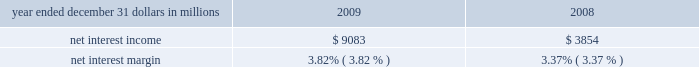Consolidated income statement review net income for 2009 was $ 2.4 billion and for 2008 was $ 914 million .
Amounts for 2009 include operating results of national city and the fourth quarter impact of a $ 687 million after-tax gain related to blackrock 2019s acquisition of bgi .
Increases in income statement comparisons to 2008 , except as noted , are primarily due to the operating results of national city .
Our consolidated income statement is presented in item 8 of this report .
Net interest income and net interest margin year ended december 31 dollars in millions 2009 2008 .
Changes in net interest income and margin result from the interaction of the volume and composition of interest-earning assets and related yields , interest-bearing liabilities and related rates paid , and noninterest-bearing sources of funding .
See statistical information 2013 analysis of year-to-year changes in net interest ( unaudited ) income and average consolidated balance sheet and net interest analysis in item 8 of this report for additional information .
Higher net interest income for 2009 compared with 2008 reflected the increase in average interest-earning assets due to national city and the improvement in the net interest margin .
The net interest margin was 3.82% ( 3.82 % ) for 2009 and 3.37% ( 3.37 % ) for 2008 .
The following factors impacted the comparison : 2022 a decrease in the rate accrued on interest-bearing liabilities of 97 basis points .
The rate accrued on interest-bearing deposits , the largest component , decreased 107 basis points .
2022 these factors were partially offset by a 45 basis point decrease in the yield on interest-earning assets .
The yield on loans , which represented the largest portion of our earning assets in 2009 , decreased 30 basis points .
2022 in addition , the impact of noninterest-bearing sources of funding decreased 7 basis points .
For comparing to the broader market , the average federal funds rate was .16% ( .16 % ) for 2009 compared with 1.94% ( 1.94 % ) for 2008 .
We expect our net interest income for 2010 will likely be modestly lower as a result of cash recoveries on purchased impaired loans in 2009 and additional run-off of higher- yielding assets , which could be mitigated by rising interest rates .
This assumes our current expectations for interest rates and economic conditions 2013 we include our current economic assumptions underlying our forward-looking statements in the cautionary statement regarding forward-looking information section of this item 7 .
Noninterest income summary noninterest income was $ 7.1 billion for 2009 and $ 2.4 billion for 2008 .
Noninterest income for 2009 included the following : 2022 the gain on blackrock/bgi transaction of $ 1.076 billion , 2022 net credit-related other-than-temporary impairments ( otti ) on debt and equity securities of $ 577 million , 2022 net gains on sales of securities of $ 550 million , 2022 gains on hedging of residential mortgage servicing rights of $ 355 million , 2022 valuation and sale income related to our commercial mortgage loans held for sale , net of hedges , of $ 107 million , 2022 gains of $ 103 million related to our blackrock ltip shares adjustment in the first quarter , and net losses on private equity and alternative investments of $ 93 million .
Noninterest income for 2008 included the following : 2022 net otti on debt and equity securities of $ 312 million , 2022 gains of $ 246 million related to our blackrock ltip shares adjustment , 2022 valuation and sale losses related to our commercial mortgage loans held for sale , net of hedges , of $ 197 million , 2022 impairment and other losses related to private equity and alternative investments of $ 180 million , 2022 income from hilliard lyons totaling $ 164 million , including the first quarter gain of $ 114 million from the sale of this business , 2022 net gains on sales of securities of $ 106 million , and 2022 a gain of $ 95 million related to the redemption of a portion of our visa class b common shares related to visa 2019s march 2008 initial public offering .
Additional analysis asset management revenue increased $ 172 million to $ 858 million in 2009 , compared with $ 686 million in 2008 .
This increase reflected improving equity markets , new business generation and a shift in assets into higher yielding equity investments during the second half of 2009 .
Assets managed totaled $ 103 billion at both december 31 , 2009 and 2008 , including the impact of national city .
The asset management group section of the business segments review section of this item 7 includes further discussion of assets under management .
Consumer services fees totaled $ 1.290 billion in 2009 compared with $ 623 million in 2008 .
Service charges on deposits totaled $ 950 million for 2009 and $ 372 million for 2008 .
Both increases were primarily driven by the impact of the national city acquisition .
Reduced consumer spending .
What was the percentage change in the asset management revenue from 2008 to 2009? 
Computations: (172 / 686)
Answer: 0.25073. Consolidated income statement review net income for 2009 was $ 2.4 billion and for 2008 was $ 914 million .
Amounts for 2009 include operating results of national city and the fourth quarter impact of a $ 687 million after-tax gain related to blackrock 2019s acquisition of bgi .
Increases in income statement comparisons to 2008 , except as noted , are primarily due to the operating results of national city .
Our consolidated income statement is presented in item 8 of this report .
Net interest income and net interest margin year ended december 31 dollars in millions 2009 2008 .
Changes in net interest income and margin result from the interaction of the volume and composition of interest-earning assets and related yields , interest-bearing liabilities and related rates paid , and noninterest-bearing sources of funding .
See statistical information 2013 analysis of year-to-year changes in net interest ( unaudited ) income and average consolidated balance sheet and net interest analysis in item 8 of this report for additional information .
Higher net interest income for 2009 compared with 2008 reflected the increase in average interest-earning assets due to national city and the improvement in the net interest margin .
The net interest margin was 3.82% ( 3.82 % ) for 2009 and 3.37% ( 3.37 % ) for 2008 .
The following factors impacted the comparison : 2022 a decrease in the rate accrued on interest-bearing liabilities of 97 basis points .
The rate accrued on interest-bearing deposits , the largest component , decreased 107 basis points .
2022 these factors were partially offset by a 45 basis point decrease in the yield on interest-earning assets .
The yield on loans , which represented the largest portion of our earning assets in 2009 , decreased 30 basis points .
2022 in addition , the impact of noninterest-bearing sources of funding decreased 7 basis points .
For comparing to the broader market , the average federal funds rate was .16% ( .16 % ) for 2009 compared with 1.94% ( 1.94 % ) for 2008 .
We expect our net interest income for 2010 will likely be modestly lower as a result of cash recoveries on purchased impaired loans in 2009 and additional run-off of higher- yielding assets , which could be mitigated by rising interest rates .
This assumes our current expectations for interest rates and economic conditions 2013 we include our current economic assumptions underlying our forward-looking statements in the cautionary statement regarding forward-looking information section of this item 7 .
Noninterest income summary noninterest income was $ 7.1 billion for 2009 and $ 2.4 billion for 2008 .
Noninterest income for 2009 included the following : 2022 the gain on blackrock/bgi transaction of $ 1.076 billion , 2022 net credit-related other-than-temporary impairments ( otti ) on debt and equity securities of $ 577 million , 2022 net gains on sales of securities of $ 550 million , 2022 gains on hedging of residential mortgage servicing rights of $ 355 million , 2022 valuation and sale income related to our commercial mortgage loans held for sale , net of hedges , of $ 107 million , 2022 gains of $ 103 million related to our blackrock ltip shares adjustment in the first quarter , and net losses on private equity and alternative investments of $ 93 million .
Noninterest income for 2008 included the following : 2022 net otti on debt and equity securities of $ 312 million , 2022 gains of $ 246 million related to our blackrock ltip shares adjustment , 2022 valuation and sale losses related to our commercial mortgage loans held for sale , net of hedges , of $ 197 million , 2022 impairment and other losses related to private equity and alternative investments of $ 180 million , 2022 income from hilliard lyons totaling $ 164 million , including the first quarter gain of $ 114 million from the sale of this business , 2022 net gains on sales of securities of $ 106 million , and 2022 a gain of $ 95 million related to the redemption of a portion of our visa class b common shares related to visa 2019s march 2008 initial public offering .
Additional analysis asset management revenue increased $ 172 million to $ 858 million in 2009 , compared with $ 686 million in 2008 .
This increase reflected improving equity markets , new business generation and a shift in assets into higher yielding equity investments during the second half of 2009 .
Assets managed totaled $ 103 billion at both december 31 , 2009 and 2008 , including the impact of national city .
The asset management group section of the business segments review section of this item 7 includes further discussion of assets under management .
Consumer services fees totaled $ 1.290 billion in 2009 compared with $ 623 million in 2008 .
Service charges on deposits totaled $ 950 million for 2009 and $ 372 million for 2008 .
Both increases were primarily driven by the impact of the national city acquisition .
Reduced consumer spending .
What was the average net interest margin in% ( in % ) for 2009 and 2008.? 
Computations: ((3.82 + 3.37) / 2)
Answer: 3.595. Consolidated income statement review net income for 2009 was $ 2.4 billion and for 2008 was $ 914 million .
Amounts for 2009 include operating results of national city and the fourth quarter impact of a $ 687 million after-tax gain related to blackrock 2019s acquisition of bgi .
Increases in income statement comparisons to 2008 , except as noted , are primarily due to the operating results of national city .
Our consolidated income statement is presented in item 8 of this report .
Net interest income and net interest margin year ended december 31 dollars in millions 2009 2008 .
Changes in net interest income and margin result from the interaction of the volume and composition of interest-earning assets and related yields , interest-bearing liabilities and related rates paid , and noninterest-bearing sources of funding .
See statistical information 2013 analysis of year-to-year changes in net interest ( unaudited ) income and average consolidated balance sheet and net interest analysis in item 8 of this report for additional information .
Higher net interest income for 2009 compared with 2008 reflected the increase in average interest-earning assets due to national city and the improvement in the net interest margin .
The net interest margin was 3.82% ( 3.82 % ) for 2009 and 3.37% ( 3.37 % ) for 2008 .
The following factors impacted the comparison : 2022 a decrease in the rate accrued on interest-bearing liabilities of 97 basis points .
The rate accrued on interest-bearing deposits , the largest component , decreased 107 basis points .
2022 these factors were partially offset by a 45 basis point decrease in the yield on interest-earning assets .
The yield on loans , which represented the largest portion of our earning assets in 2009 , decreased 30 basis points .
2022 in addition , the impact of noninterest-bearing sources of funding decreased 7 basis points .
For comparing to the broader market , the average federal funds rate was .16% ( .16 % ) for 2009 compared with 1.94% ( 1.94 % ) for 2008 .
We expect our net interest income for 2010 will likely be modestly lower as a result of cash recoveries on purchased impaired loans in 2009 and additional run-off of higher- yielding assets , which could be mitigated by rising interest rates .
This assumes our current expectations for interest rates and economic conditions 2013 we include our current economic assumptions underlying our forward-looking statements in the cautionary statement regarding forward-looking information section of this item 7 .
Noninterest income summary noninterest income was $ 7.1 billion for 2009 and $ 2.4 billion for 2008 .
Noninterest income for 2009 included the following : 2022 the gain on blackrock/bgi transaction of $ 1.076 billion , 2022 net credit-related other-than-temporary impairments ( otti ) on debt and equity securities of $ 577 million , 2022 net gains on sales of securities of $ 550 million , 2022 gains on hedging of residential mortgage servicing rights of $ 355 million , 2022 valuation and sale income related to our commercial mortgage loans held for sale , net of hedges , of $ 107 million , 2022 gains of $ 103 million related to our blackrock ltip shares adjustment in the first quarter , and net losses on private equity and alternative investments of $ 93 million .
Noninterest income for 2008 included the following : 2022 net otti on debt and equity securities of $ 312 million , 2022 gains of $ 246 million related to our blackrock ltip shares adjustment , 2022 valuation and sale losses related to our commercial mortgage loans held for sale , net of hedges , of $ 197 million , 2022 impairment and other losses related to private equity and alternative investments of $ 180 million , 2022 income from hilliard lyons totaling $ 164 million , including the first quarter gain of $ 114 million from the sale of this business , 2022 net gains on sales of securities of $ 106 million , and 2022 a gain of $ 95 million related to the redemption of a portion of our visa class b common shares related to visa 2019s march 2008 initial public offering .
Additional analysis asset management revenue increased $ 172 million to $ 858 million in 2009 , compared with $ 686 million in 2008 .
This increase reflected improving equity markets , new business generation and a shift in assets into higher yielding equity investments during the second half of 2009 .
Assets managed totaled $ 103 billion at both december 31 , 2009 and 2008 , including the impact of national city .
The asset management group section of the business segments review section of this item 7 includes further discussion of assets under management .
Consumer services fees totaled $ 1.290 billion in 2009 compared with $ 623 million in 2008 .
Service charges on deposits totaled $ 950 million for 2009 and $ 372 million for 2008 .
Both increases were primarily driven by the impact of the national city acquisition .
Reduced consumer spending .
What was the average of noninterest income in 2008 and 2009 , in billions? 
Computations: ((7.1 + 2.4) / 2)
Answer: 4.75. 